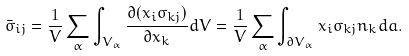<formula> <loc_0><loc_0><loc_500><loc_500>\bar { \sigma } _ { i j } = \frac { 1 } { V } \sum _ { \alpha } { \int _ { V _ { \alpha } } { \frac { \partial ( x _ { i } \sigma _ { k j } ) } { \partial x _ { k } } d V } } = \frac { 1 } { V } \sum _ { \alpha } { \int _ { \partial V _ { \alpha } } { x _ { i } \sigma _ { k j } n _ { k } d a } } .</formula> 